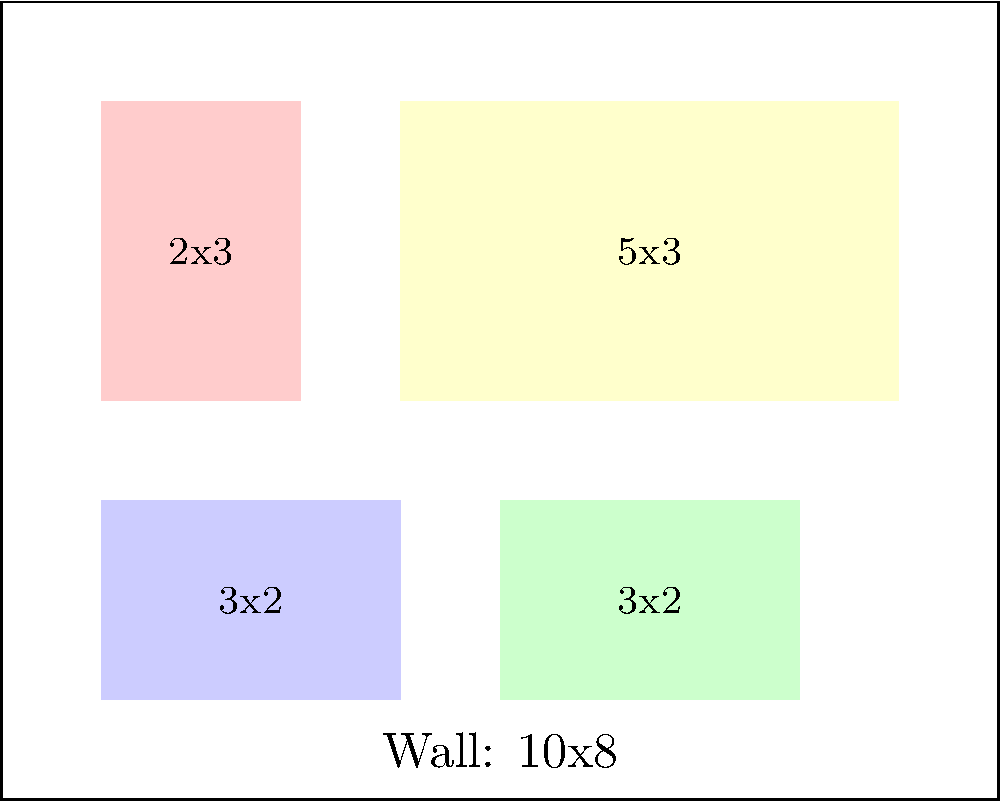You want to cover as much of your bedroom wall as possible with posters of your favorite pop singer. The wall measures 10 feet wide by 8 feet high. You have the following posters available:
- 2 posters measuring 3 feet x 2 feet
- 1 poster measuring 2 feet x 3 feet
- 1 poster measuring 5 feet x 3 feet

What is the maximum percentage of the wall that can be covered by these posters, assuming they don't overlap and are placed in the arrangement shown in the diagram? Let's approach this step-by-step:

1) First, let's calculate the total area of the wall:
   Wall area = $10 \text{ ft} \times 8 \text{ ft} = 80 \text{ sq ft}$

2) Now, let's calculate the area of each type of poster:
   - 3 ft x 2 ft posters: $3 \text{ ft} \times 2 \text{ ft} = 6 \text{ sq ft}$ each
   - 2 ft x 3 ft poster: $2 \text{ ft} \times 3 \text{ ft} = 6 \text{ sq ft}$
   - 5 ft x 3 ft poster: $5 \text{ ft} \times 3 \text{ ft} = 15 \text{ sq ft}$

3) Calculate the total area covered by all posters:
   $(6 \text{ sq ft} \times 2) + 6 \text{ sq ft} + 15 \text{ sq ft} = 33 \text{ sq ft}$

4) To find the percentage of the wall covered, divide the area covered by posters by the total wall area and multiply by 100:

   $$\text{Percentage covered} = \frac{\text{Area covered by posters}}{\text{Total wall area}} \times 100\%$$

   $$= \frac{33 \text{ sq ft}}{80 \text{ sq ft}} \times 100\% = 0.4125 \times 100\% = 41.25\%$$

Therefore, the maximum percentage of the wall that can be covered by these posters in the given arrangement is 41.25%.
Answer: 41.25% 